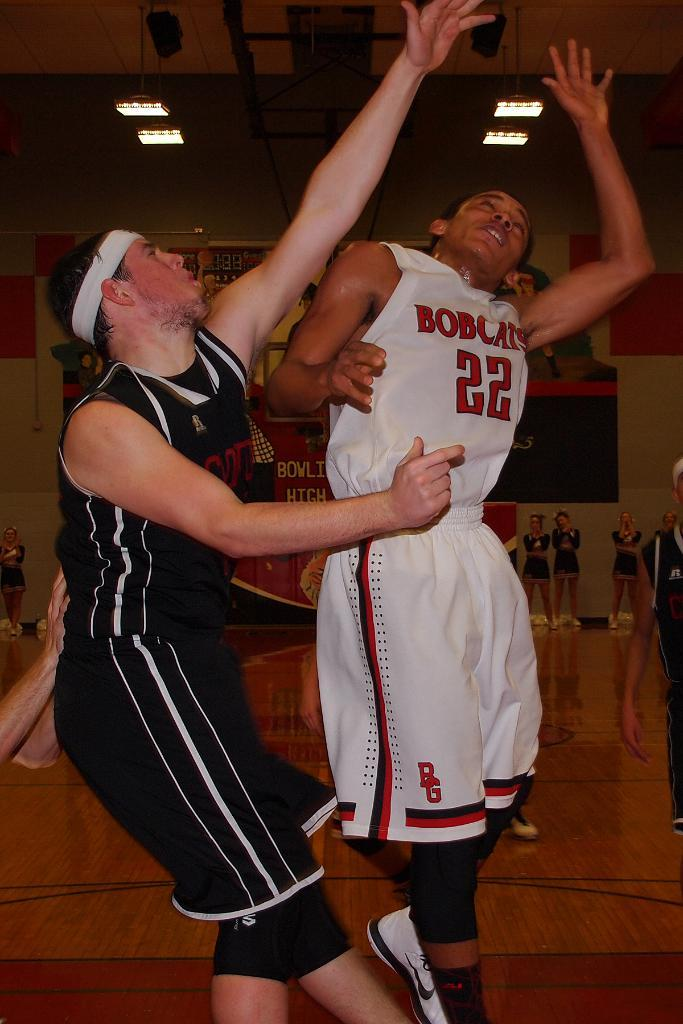<image>
Give a short and clear explanation of the subsequent image. Player wearing number 22 for the Bobcats going for a rebound. 